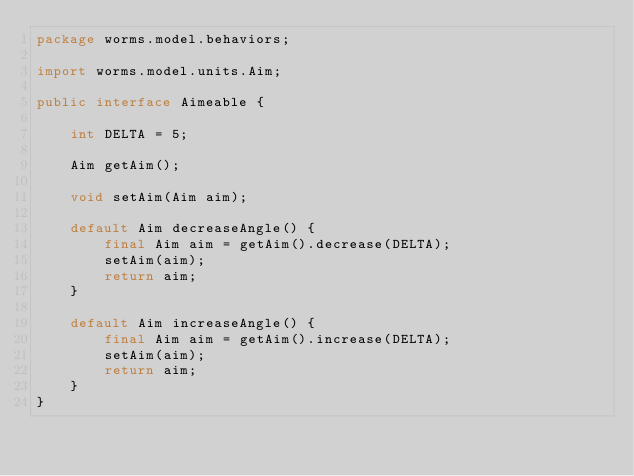Convert code to text. <code><loc_0><loc_0><loc_500><loc_500><_Java_>package worms.model.behaviors;

import worms.model.units.Aim;

public interface Aimeable {

    int DELTA = 5;

    Aim getAim();

    void setAim(Aim aim);

    default Aim decreaseAngle() {
        final Aim aim = getAim().decrease(DELTA);
        setAim(aim);
        return aim;
    }

    default Aim increaseAngle() {
        final Aim aim = getAim().increase(DELTA);
        setAim(aim);
        return aim;
    }
}
</code> 